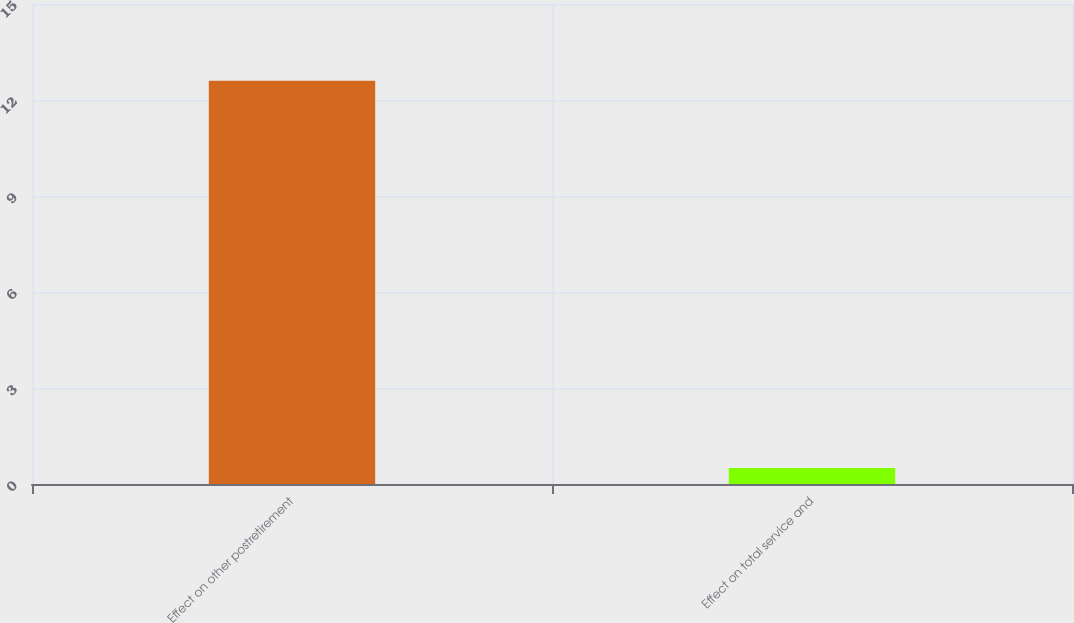Convert chart. <chart><loc_0><loc_0><loc_500><loc_500><bar_chart><fcel>Effect on other postretirement<fcel>Effect on total service and<nl><fcel>12.6<fcel>0.5<nl></chart> 